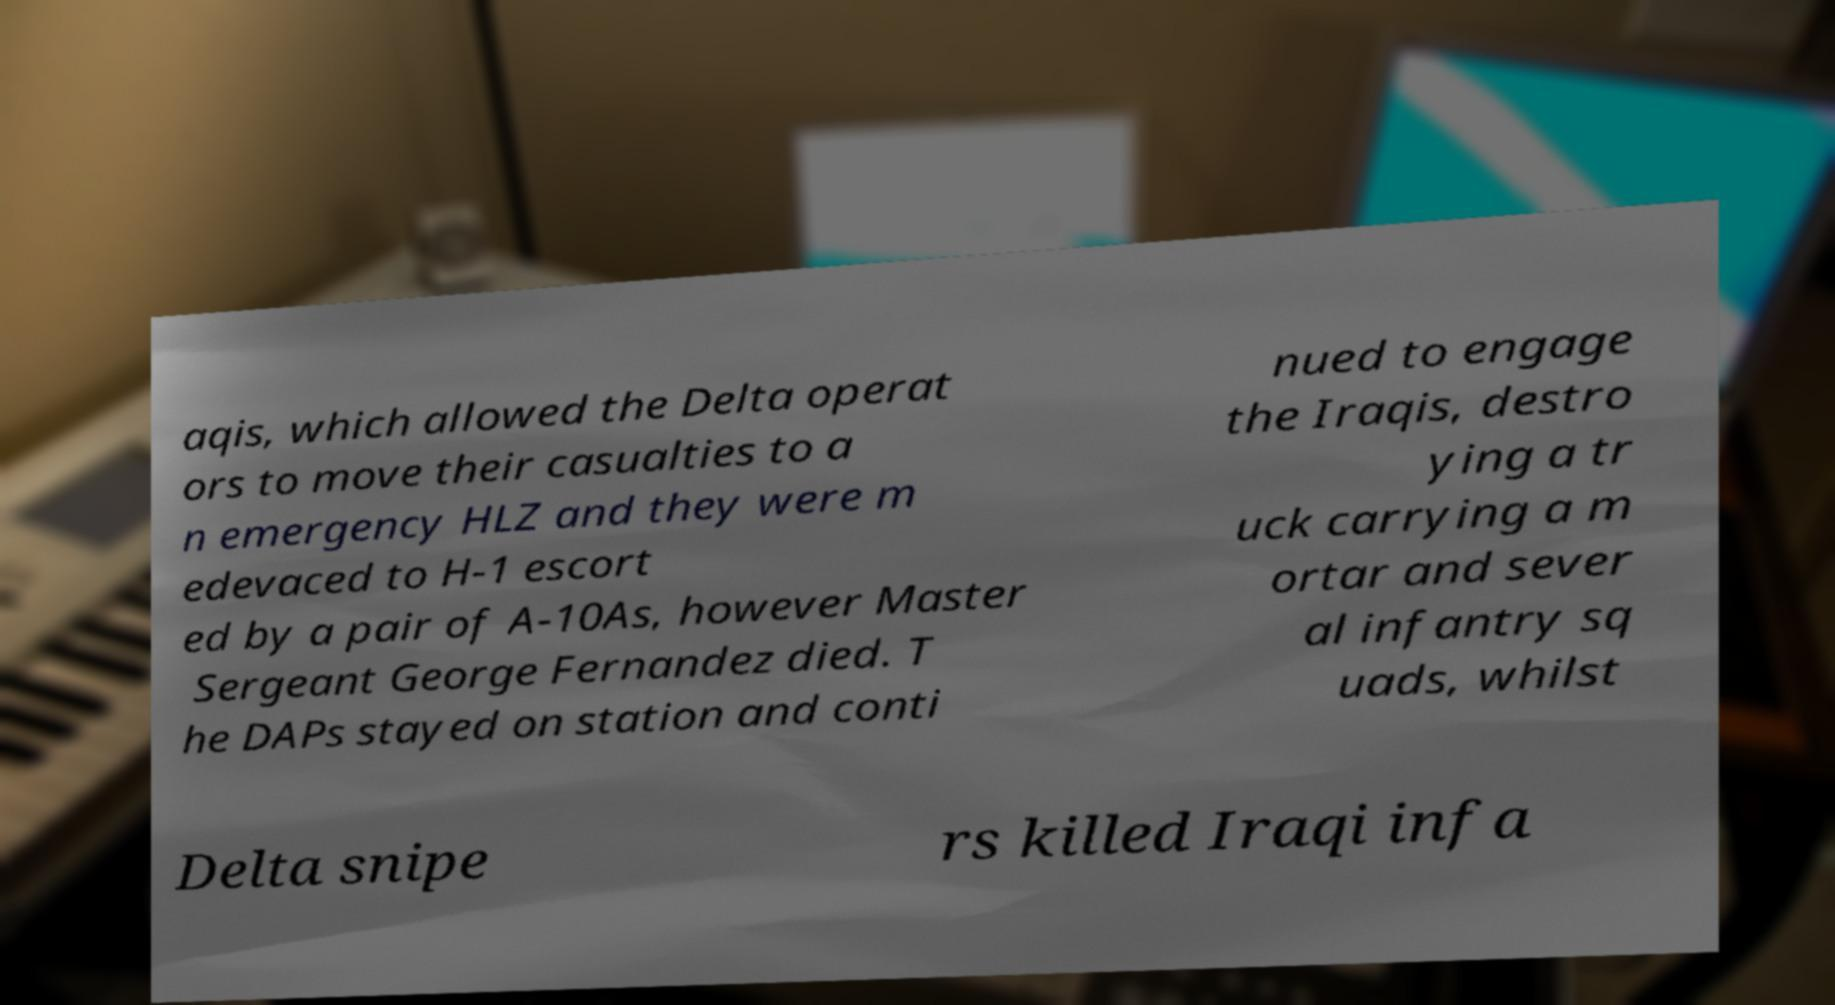There's text embedded in this image that I need extracted. Can you transcribe it verbatim? aqis, which allowed the Delta operat ors to move their casualties to a n emergency HLZ and they were m edevaced to H-1 escort ed by a pair of A-10As, however Master Sergeant George Fernandez died. T he DAPs stayed on station and conti nued to engage the Iraqis, destro ying a tr uck carrying a m ortar and sever al infantry sq uads, whilst Delta snipe rs killed Iraqi infa 